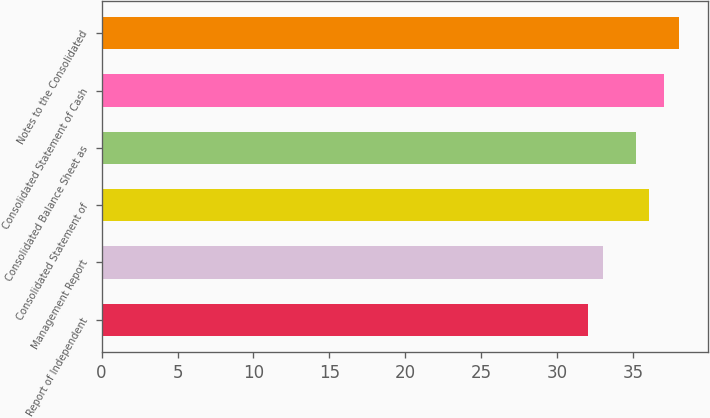Convert chart to OTSL. <chart><loc_0><loc_0><loc_500><loc_500><bar_chart><fcel>Report of Independent<fcel>Management Report<fcel>Consolidated Statement of<fcel>Consolidated Balance Sheet as<fcel>Consolidated Statement of Cash<fcel>Notes to the Consolidated<nl><fcel>32<fcel>33<fcel>36<fcel>35.2<fcel>37<fcel>38<nl></chart> 